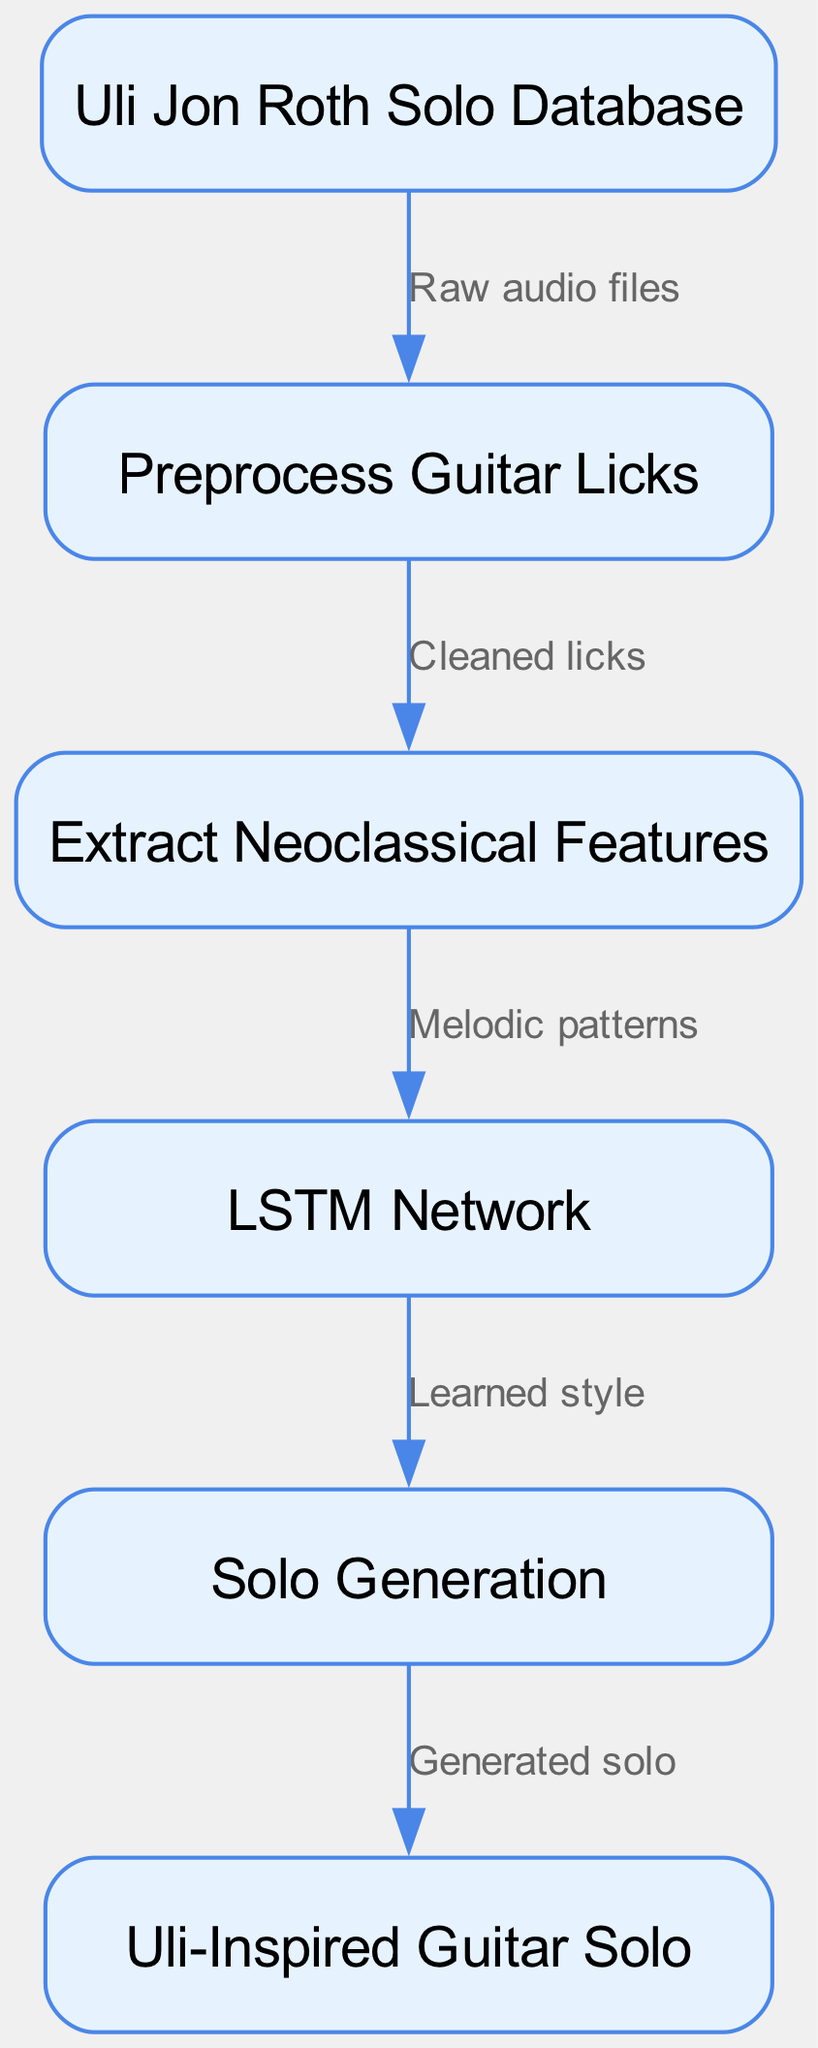What is the first step in the process? The first step is represented by the "Uli Jon Roth Solo Database" node, which is the input for the process. This indicates where the initial data comes from before any processing occurs.
Answer: Uli Jon Roth Solo Database How many nodes are present in the diagram? By counting the number of distinct nodes in the diagram, we find that there are six nodes representing different stages in the process.
Answer: 6 What type of network is employed in the diagram? The "LSTM Network" node specifies the type of network used in the process, which is a Long Short-Term Memory network, suitable for sequential data like music.
Answer: LSTM Network What is the output of the diagram? The output node labeled "Uli-Inspired Guitar Solo" indicates the final product generated by the process, which is the targeted outcome of the entire flow.
Answer: Uli-Inspired Guitar Solo Which node follows the feature extraction step? The edge leading out of the "Extract Neoclassical Features" node points directly to the "LSTM Network" node, indicating that the next step involves passing the extracted features to the network for further processing.
Answer: LSTM Network What kind of patterns does the feature extraction extract? The diagram indicates that the "Extract Neoclassical Features" node outputs "Melodic patterns," which highlights the specific elements it focuses on during processing.
Answer: Melodic patterns Describe the purpose of the preprocess node in the diagram. The "Preprocess Guitar Licks" node serves as a step where the raw audio files from the database are cleaned and organized so that they can be effectively used in subsequent steps.
Answer: Cleaned licks How does the generation step relate to the previous one? The edge between the "Solo Generation" and "LSTM Network" nodes shows that the generation step is reliant on the "Learned style" output from the LSTM network, highlighting the sequential nature of the process.
Answer: Learned style What does the generation step produce? According to the diagram, the output of the "Solo Generation" step is "Generated solo," which is the end product of the entire neural network process described in the diagram.
Answer: Generated solo 